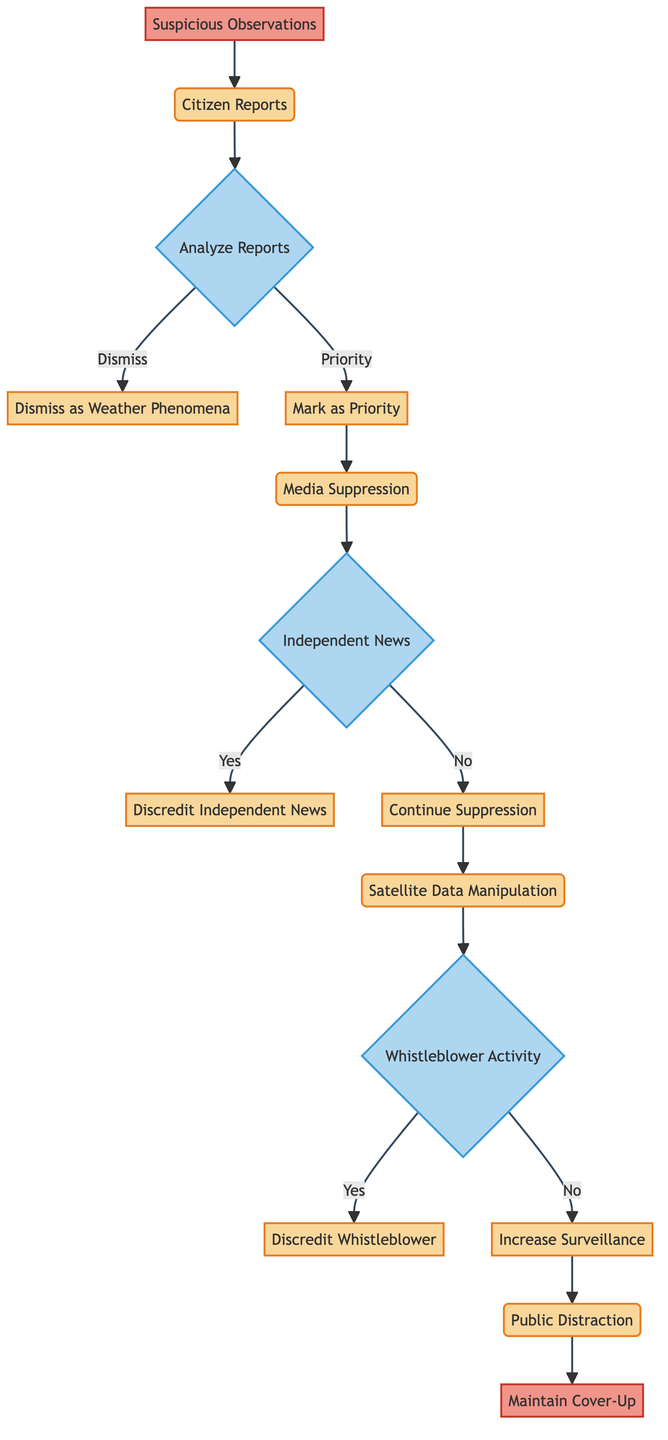What is the starting point of the flowchart? The flowchart begins with the node labeled "Suspicious Observations." This is the input that initiates the entire process depicted in the diagram.
Answer: Suspicious Observations How many processes are in the flowchart? By examining the nodes labeled as processes, we find there are four processes: "Citizen Reports," "Media Suppression," "Satellite Data Manipulation," and "Public Distraction." Thus, the total is four processes.
Answer: 4 What happens if the reports are marked as a priority? If the reports are marked as a priority, the flow continues to "Media Suppression." This indicates that prioritized reports further trigger actions to suppress information rather than dismissing them outright.
Answer: Media Suppression What is the result of independent news successfully reporting the anomaly? If independent news outlets report on the anomaly, the flowchart indicates that the response is to "Discredit Independent News," focusing on efforts to undermine alternative narratives.
Answer: Discredit Independent News What occurs if there is no whistleblower activity? According to the flowchart, if there is no whistleblower activity, the next action is "Increase Surveillance." This suggests precautionary measures are taken to monitor potential leaks of information.
Answer: Increase Surveillance Which process follows the decision of whether to discredit a whistleblower or not? Following the decision regarding the whistleblower activity, the next process indicated is "Public Distraction," which serves to divert public attention regardless of the previous decision.
Answer: Public Distraction What is the endpoint of this flowchart? The endpoint of the flowchart is labeled as "Maintain Cover-Up," signifying the ultimate goal of the actions presented in the diagram.
Answer: Maintain Cover-Up What does the flowchart indicate happens after citizen reports are analyzed and marked as a priority? After citizen reports are analyzed and marked as a priority, the next step is "Media Suppression," indicating continued efforts to control the narrative surrounding the findings.
Answer: Media Suppression How does the diagram categorize the interaction with independent news? The diagram provides a decision point labeled "Independent News," outlining two possible outcomes based on whether they report on the anomaly, either resulting in discrediting or continued suppression, thus categorizing it as a critical junction in information flow.
Answer: Independent News 